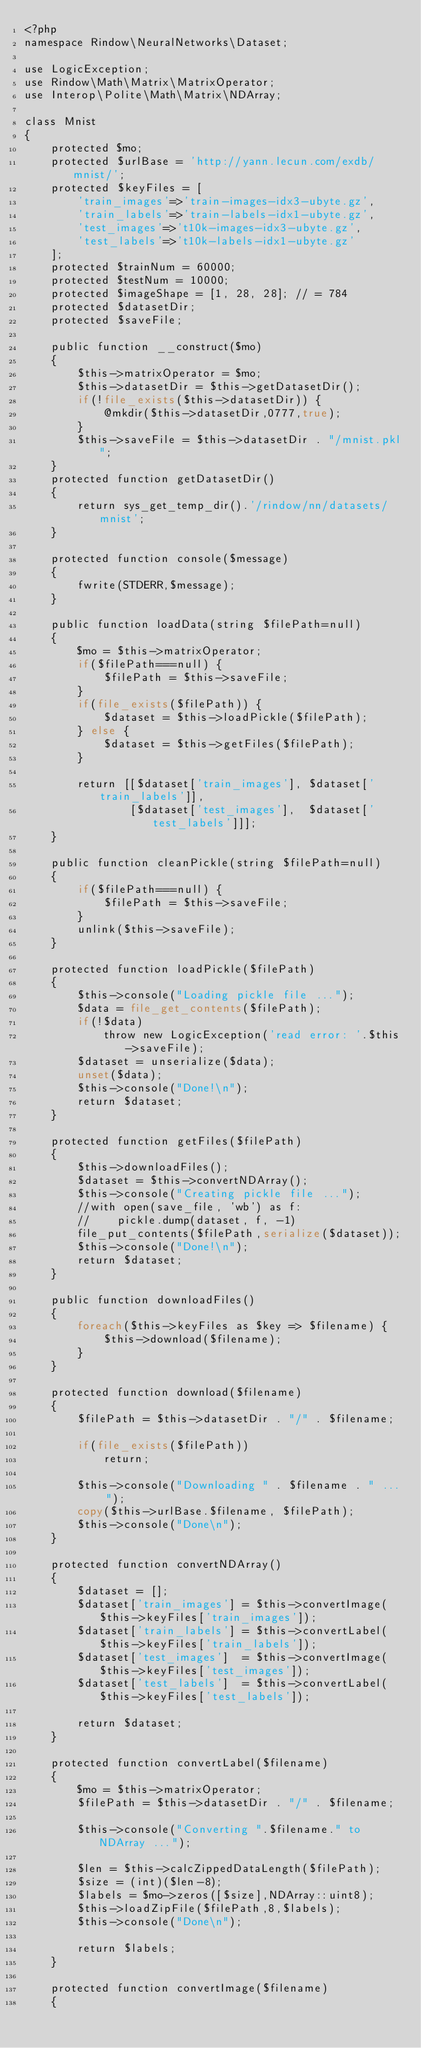Convert code to text. <code><loc_0><loc_0><loc_500><loc_500><_PHP_><?php
namespace Rindow\NeuralNetworks\Dataset;

use LogicException;
use Rindow\Math\Matrix\MatrixOperator;
use Interop\Polite\Math\Matrix\NDArray;

class Mnist
{
    protected $mo;
    protected $urlBase = 'http://yann.lecun.com/exdb/mnist/';
    protected $keyFiles = [
        'train_images'=>'train-images-idx3-ubyte.gz',
        'train_labels'=>'train-labels-idx1-ubyte.gz',
        'test_images'=>'t10k-images-idx3-ubyte.gz',
        'test_labels'=>'t10k-labels-idx1-ubyte.gz'
    ];
    protected $trainNum = 60000;
    protected $testNum = 10000;
    protected $imageShape = [1, 28, 28]; // = 784
    protected $datasetDir;
    protected $saveFile;

    public function __construct($mo)
    {
        $this->matrixOperator = $mo;
        $this->datasetDir = $this->getDatasetDir();
        if(!file_exists($this->datasetDir)) {
            @mkdir($this->datasetDir,0777,true);
        }
        $this->saveFile = $this->datasetDir . "/mnist.pkl";
    }
    protected function getDatasetDir()
    {
        return sys_get_temp_dir().'/rindow/nn/datasets/mnist';
    }

    protected function console($message)
    {
        fwrite(STDERR,$message);
    }

    public function loadData(string $filePath=null)
    {
        $mo = $this->matrixOperator;
        if($filePath===null) {
            $filePath = $this->saveFile;
        }
        if(file_exists($filePath)) {
            $dataset = $this->loadPickle($filePath);
        } else {
            $dataset = $this->getFiles($filePath);
        }

        return [[$dataset['train_images'], $dataset['train_labels']],
                [$dataset['test_images'],  $dataset['test_labels']]];
    }

    public function cleanPickle(string $filePath=null)
    {
        if($filePath===null) {
            $filePath = $this->saveFile;
        }
        unlink($this->saveFile);
    }

    protected function loadPickle($filePath)
    {
        $this->console("Loading pickle file ...");
        $data = file_get_contents($filePath);
        if(!$data)
            throw new LogicException('read error: '.$this->saveFile);
        $dataset = unserialize($data);
        unset($data);
        $this->console("Done!\n");
        return $dataset;
    }

    protected function getFiles($filePath)
    {
        $this->downloadFiles();
        $dataset = $this->convertNDArray();
        $this->console("Creating pickle file ...");
        //with open(save_file, 'wb') as f:
        //    pickle.dump(dataset, f, -1)
        file_put_contents($filePath,serialize($dataset));
        $this->console("Done!\n");
        return $dataset;
    }

    public function downloadFiles()
    {
        foreach($this->keyFiles as $key => $filename) {
            $this->download($filename);
        }
    }

    protected function download($filename)
    {
        $filePath = $this->datasetDir . "/" . $filename;

        if(file_exists($filePath))
            return;

        $this->console("Downloading " . $filename . " ... ");
        copy($this->urlBase.$filename, $filePath);
        $this->console("Done\n");
    }

    protected function convertNDArray()
    {
        $dataset = [];
        $dataset['train_images'] = $this->convertImage($this->keyFiles['train_images']);
        $dataset['train_labels'] = $this->convertLabel($this->keyFiles['train_labels']);
        $dataset['test_images']  = $this->convertImage($this->keyFiles['test_images']);
        $dataset['test_labels']  = $this->convertLabel($this->keyFiles['test_labels']);

        return $dataset;
    }

    protected function convertLabel($filename)
    {
        $mo = $this->matrixOperator;
        $filePath = $this->datasetDir . "/" . $filename;

        $this->console("Converting ".$filename." to NDArray ...");

        $len = $this->calcZippedDataLength($filePath);
        $size = (int)($len-8);
        $labels = $mo->zeros([$size],NDArray::uint8);
        $this->loadZipFile($filePath,8,$labels);
        $this->console("Done\n");

        return $labels;
    }

    protected function convertImage($filename)
    {</code> 